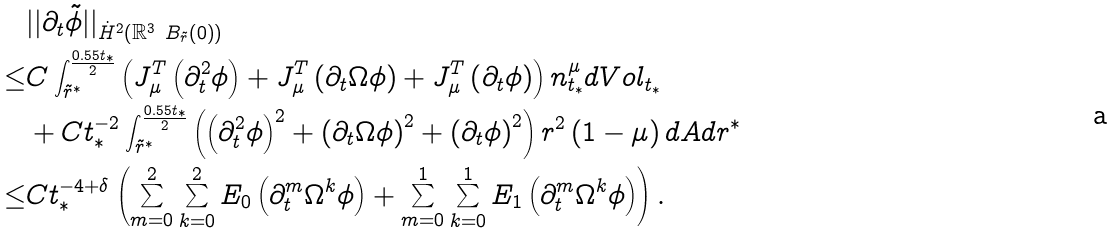Convert formula to latex. <formula><loc_0><loc_0><loc_500><loc_500>& | | \partial _ { t } \tilde { \phi } | | _ { \dot { H } ^ { 2 } \left ( \mathbb { R } ^ { 3 } \ B _ { \tilde { r } } \left ( 0 \right ) \right ) } \\ \leq & C \int _ { \tilde { r } ^ { * } } ^ { \frac { 0 . 5 5 t _ { * } } { 2 } } \left ( J ^ { T } _ { \mu } \left ( \partial _ { t } ^ { 2 } \phi \right ) + J ^ { T } _ { \mu } \left ( \partial _ { t } \Omega \phi \right ) + J ^ { T } _ { \mu } \left ( \partial _ { t } \phi \right ) \right ) n ^ { \mu } _ { t _ { * } } d V o l _ { t _ { * } } \\ & + C t _ { * } ^ { - 2 } \int _ { \tilde { r } ^ { * } } ^ { \frac { 0 . 5 5 t _ { * } } { 2 } } \left ( \left ( \partial _ { t } ^ { 2 } \phi \right ) ^ { 2 } + \left ( \partial _ { t } \Omega \phi \right ) ^ { 2 } + \left ( \partial _ { t } \phi \right ) ^ { 2 } \right ) r ^ { 2 } \left ( 1 - \mu \right ) d A d r ^ { * } \\ \leq & C t _ { * } ^ { - 4 + \delta } \left ( \sum _ { m = 0 } ^ { 2 } \sum _ { k = 0 } ^ { 2 } E _ { 0 } \left ( \partial _ { t } ^ { m } \Omega ^ { k } \phi \right ) + \sum _ { m = 0 } ^ { 1 } \sum _ { k = 0 } ^ { 1 } E _ { 1 } \left ( \partial _ { t } ^ { m } \Omega ^ { k } \phi \right ) \right ) .</formula> 